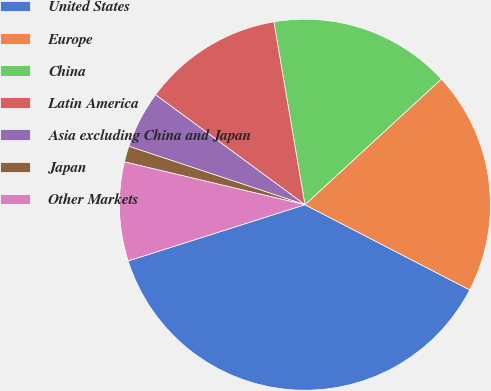<chart> <loc_0><loc_0><loc_500><loc_500><pie_chart><fcel>United States<fcel>Europe<fcel>China<fcel>Latin America<fcel>Asia excluding China and Japan<fcel>Japan<fcel>Other Markets<nl><fcel>37.5%<fcel>19.44%<fcel>15.83%<fcel>12.22%<fcel>5.0%<fcel>1.39%<fcel>8.61%<nl></chart> 